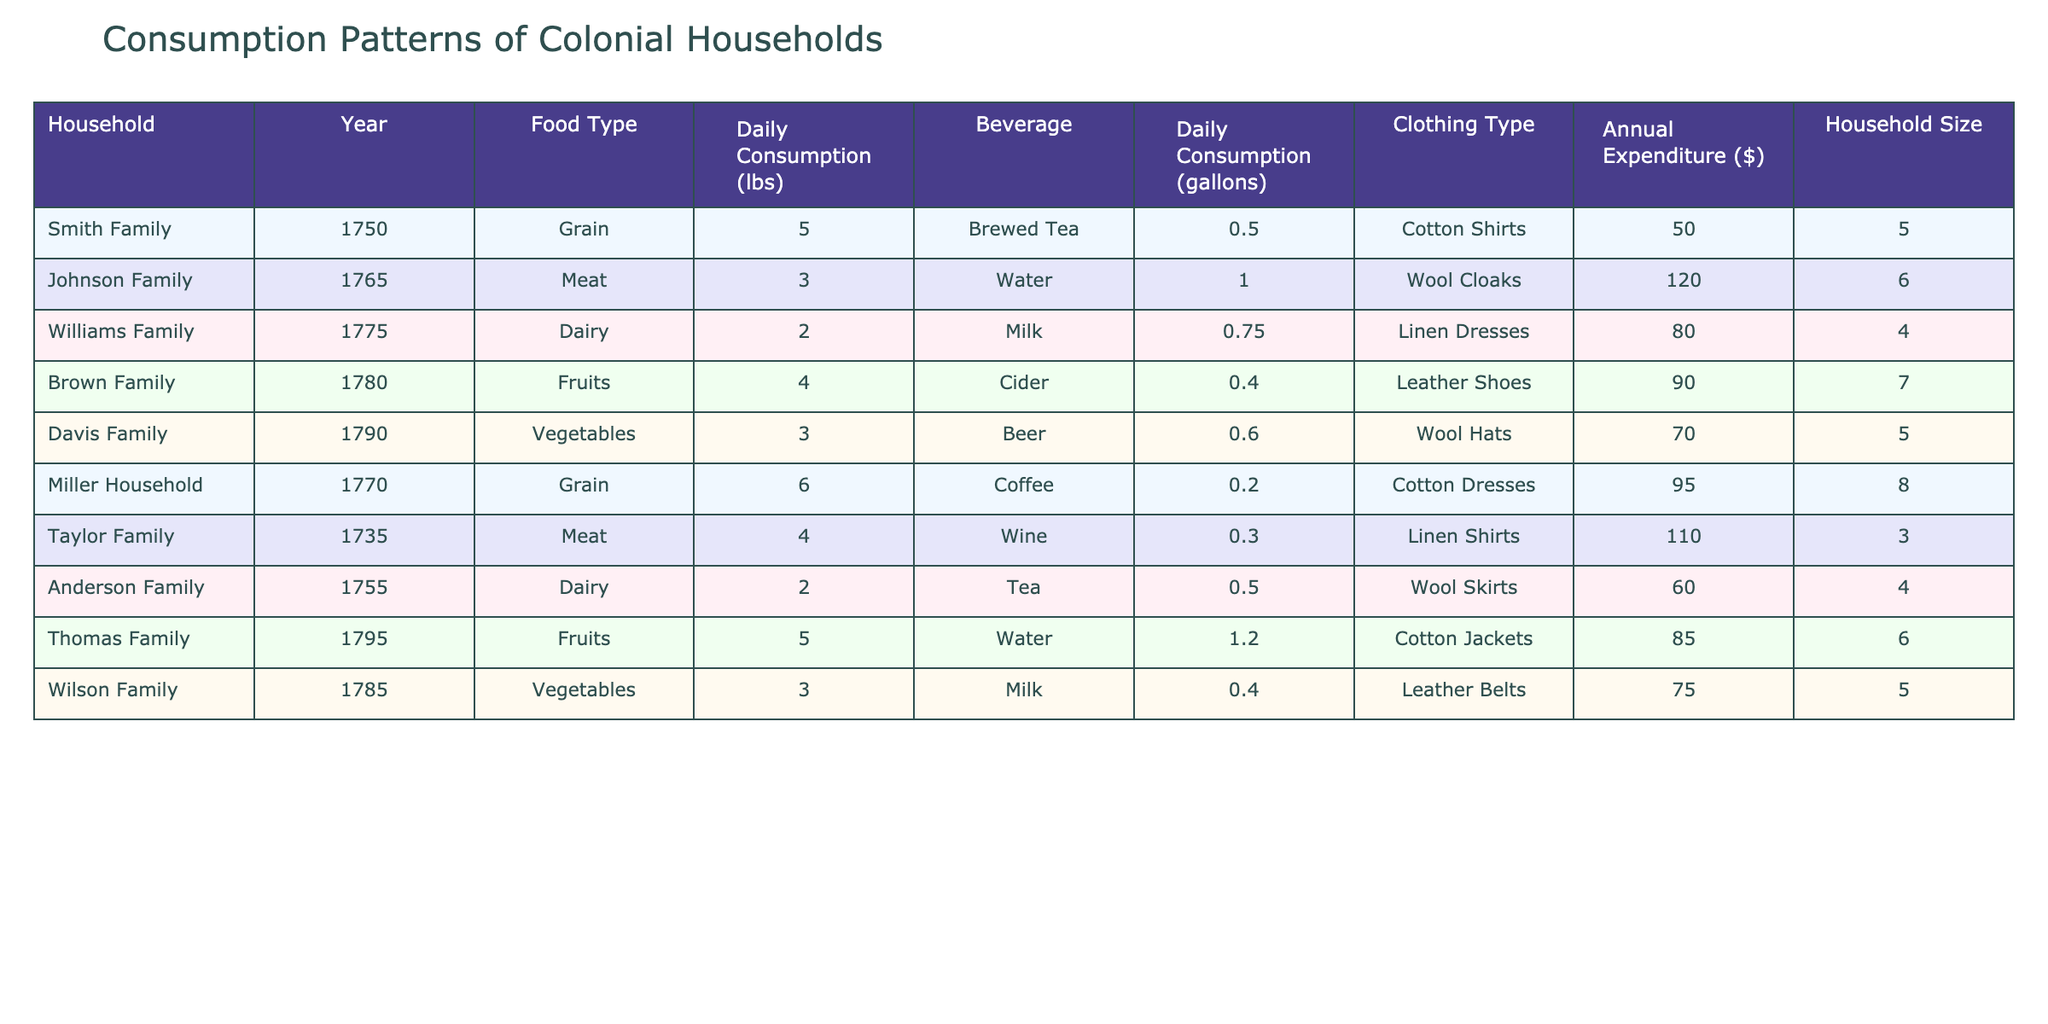What is the daily consumption of meat for the Johnson Family? The table lists the Johnson Family under the column for Daily Consumption (lbs) with food type Meat, showing their consumption as 3 lbs.
Answer: 3 lbs Which family has the highest daily grain consumption? The table indicates that Millers Household consumes 6 lbs of grain daily, which is higher than the 5 lbs consumed by the Smith Family. Therefore, Millers Household has the highest consumption.
Answer: Millers Household What's the total annual expenditure for the Brown Family and Wilson Family combined? The Brown Family's annual expenditure is 90 dollars, and the Wilson Family's is 75 dollars. Adding these amounts together, 90 + 75 = 165 dollars.
Answer: 165 dollars Is it true that the Anderson Family spends more on clothing than the Taylor Family? The Anderson Family's annual expenditure on clothing is 60 dollars, while the Taylor Family's expenditure is 110 dollars. Therefore, it is false that the Anderson Family spends more on clothing.
Answer: No What is the average daily consumption of fruits across all families? The total daily consumption of fruits is 4 lbs (Brown Family) + 5 lbs (Thomas Family) = 9 lbs. There are 2 families consuming fruits, so the average is 9 lbs / 2 = 4.5 lbs.
Answer: 4.5 lbs Which beverage is consumed most frequently across all families? By looking at the beverage column, Brewed Tea, Water, Milk, Cider, Beer, Coffee, Wine, and Tea all appear; however, Water is listed as consumed daily by both the Johnson and Thomas families, making it the most frequently consumed beverage overall.
Answer: Water What are the clothing types worn by families in 1775? The table shows that in 1775, the Williams Family wears Linen Dresses, and the Miller Household wears Cotton Dresses. Since these are the only two families listed for that year, this identifies the clothing types.
Answer: Linen Dresses, Cotton Dresses Which family has the most members and what is their average daily vegetable consumption? The Brown Family has 7 members, and their daily vegetable consumption is 3 lbs. To find the average, we can directly state their consumption is the average since they are the only family consuming vegetables listed.
Answer: 3 lbs How much more does the rent of a household with 8 members (Miller Household) spend on annual expenses than one with 3 members (Taylor Family)? The Miller Household has an annual expenditure of 95 dollars, while the Taylor Family has 110 dollars. The difference is 110 - 95 = 15 dollars, so the Miller Household spends 15 dollars less, hence the answer is negative.
Answer: -15 dollars 